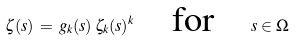<formula> <loc_0><loc_0><loc_500><loc_500>\zeta ( s ) \, = \, g _ { k } ( s ) \, \zeta _ { k } ( s ) ^ { k } \quad \text {for} \quad s \in \Omega</formula> 